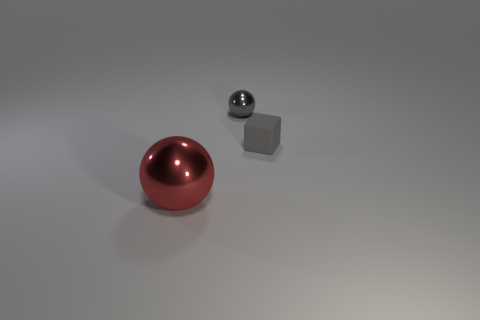Add 1 red metal balls. How many objects exist? 4 Subtract all spheres. How many objects are left? 1 Add 1 tiny gray shiny objects. How many tiny gray shiny objects are left? 2 Add 2 cyan cylinders. How many cyan cylinders exist? 2 Subtract 0 brown cylinders. How many objects are left? 3 Subtract all small gray rubber blocks. Subtract all small things. How many objects are left? 0 